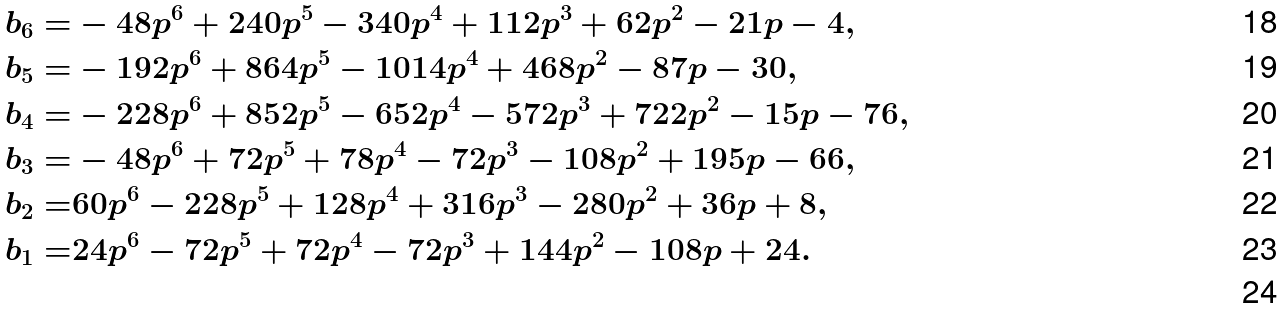Convert formula to latex. <formula><loc_0><loc_0><loc_500><loc_500>b _ { 6 } = & - 4 8 p ^ { 6 } + 2 4 0 p ^ { 5 } - 3 4 0 p ^ { 4 } + 1 1 2 p ^ { 3 } + 6 2 p ^ { 2 } - 2 1 p - 4 , \\ b _ { 5 } = & - 1 9 2 p ^ { 6 } + 8 6 4 p ^ { 5 } - 1 0 1 4 p ^ { 4 } + 4 6 8 p ^ { 2 } - 8 7 p - 3 0 , \\ b _ { 4 } = & - 2 2 8 p ^ { 6 } + 8 5 2 p ^ { 5 } - 6 5 2 p ^ { 4 } - 5 7 2 p ^ { 3 } + 7 2 2 p ^ { 2 } - 1 5 p - 7 6 , \\ b _ { 3 } = & - 4 8 p ^ { 6 } + 7 2 p ^ { 5 } + 7 8 p ^ { 4 } - 7 2 p ^ { 3 } - 1 0 8 p ^ { 2 } + 1 9 5 p - 6 6 , \\ b _ { 2 } = & 6 0 p ^ { 6 } - 2 2 8 p ^ { 5 } + 1 2 8 p ^ { 4 } + 3 1 6 p ^ { 3 } - 2 8 0 p ^ { 2 } + 3 6 p + 8 , \\ b _ { 1 } = & 2 4 p ^ { 6 } - 7 2 p ^ { 5 } + 7 2 p ^ { 4 } - 7 2 p ^ { 3 } + 1 4 4 p ^ { 2 } - 1 0 8 p + 2 4 . \\</formula> 